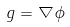Convert formula to latex. <formula><loc_0><loc_0><loc_500><loc_500>g = \nabla \phi</formula> 